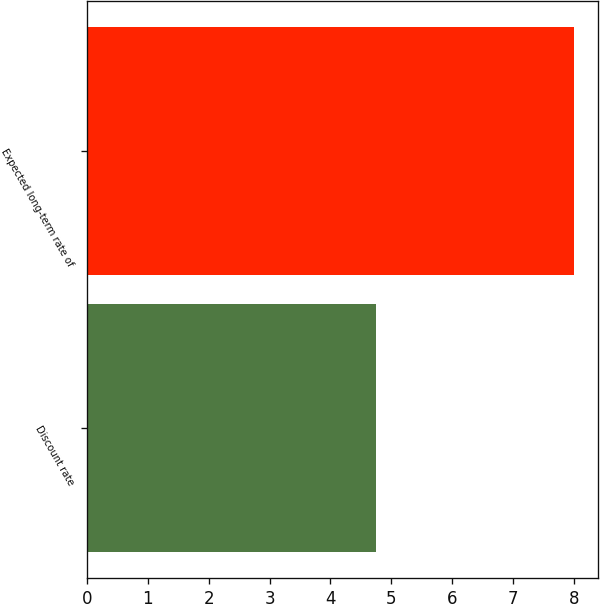Convert chart to OTSL. <chart><loc_0><loc_0><loc_500><loc_500><bar_chart><fcel>Discount rate<fcel>Expected long-term rate of<nl><fcel>4.75<fcel>8<nl></chart> 